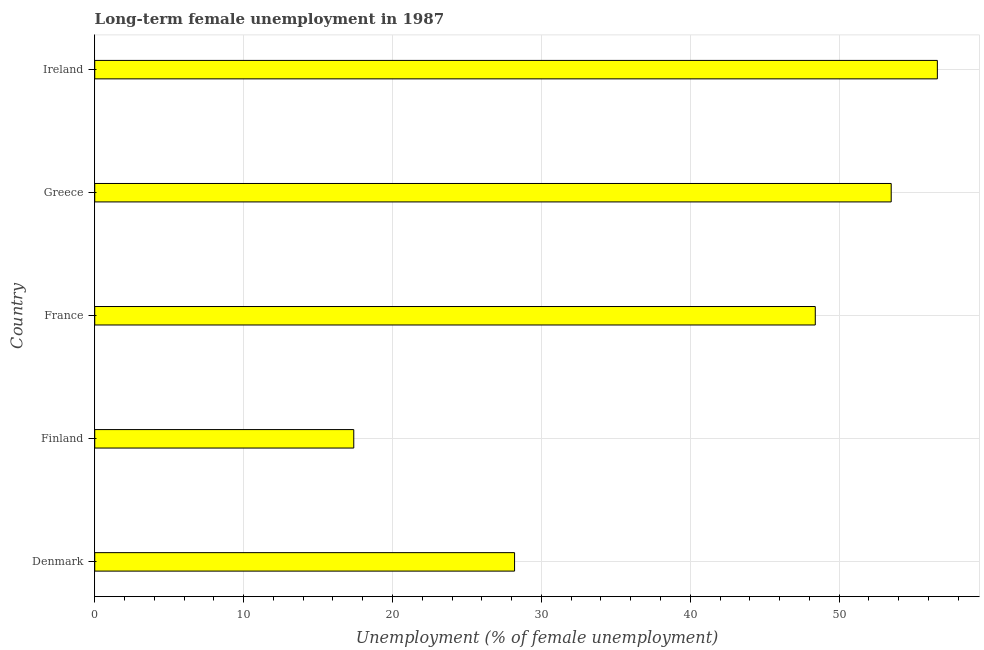What is the title of the graph?
Offer a terse response. Long-term female unemployment in 1987. What is the label or title of the X-axis?
Keep it short and to the point. Unemployment (% of female unemployment). What is the label or title of the Y-axis?
Provide a succinct answer. Country. What is the long-term female unemployment in France?
Offer a terse response. 48.4. Across all countries, what is the maximum long-term female unemployment?
Provide a short and direct response. 56.6. Across all countries, what is the minimum long-term female unemployment?
Offer a very short reply. 17.4. In which country was the long-term female unemployment maximum?
Offer a very short reply. Ireland. What is the sum of the long-term female unemployment?
Your answer should be compact. 204.1. What is the difference between the long-term female unemployment in Greece and Ireland?
Offer a very short reply. -3.1. What is the average long-term female unemployment per country?
Your answer should be compact. 40.82. What is the median long-term female unemployment?
Your answer should be very brief. 48.4. What is the ratio of the long-term female unemployment in Denmark to that in Greece?
Offer a terse response. 0.53. Is the difference between the long-term female unemployment in France and Greece greater than the difference between any two countries?
Keep it short and to the point. No. What is the difference between the highest and the lowest long-term female unemployment?
Make the answer very short. 39.2. Are all the bars in the graph horizontal?
Provide a succinct answer. Yes. How many countries are there in the graph?
Provide a succinct answer. 5. Are the values on the major ticks of X-axis written in scientific E-notation?
Your response must be concise. No. What is the Unemployment (% of female unemployment) of Denmark?
Your answer should be very brief. 28.2. What is the Unemployment (% of female unemployment) of Finland?
Offer a terse response. 17.4. What is the Unemployment (% of female unemployment) of France?
Your response must be concise. 48.4. What is the Unemployment (% of female unemployment) in Greece?
Give a very brief answer. 53.5. What is the Unemployment (% of female unemployment) in Ireland?
Provide a succinct answer. 56.6. What is the difference between the Unemployment (% of female unemployment) in Denmark and France?
Provide a succinct answer. -20.2. What is the difference between the Unemployment (% of female unemployment) in Denmark and Greece?
Your answer should be very brief. -25.3. What is the difference between the Unemployment (% of female unemployment) in Denmark and Ireland?
Your answer should be very brief. -28.4. What is the difference between the Unemployment (% of female unemployment) in Finland and France?
Your response must be concise. -31. What is the difference between the Unemployment (% of female unemployment) in Finland and Greece?
Ensure brevity in your answer.  -36.1. What is the difference between the Unemployment (% of female unemployment) in Finland and Ireland?
Ensure brevity in your answer.  -39.2. What is the difference between the Unemployment (% of female unemployment) in France and Greece?
Ensure brevity in your answer.  -5.1. What is the difference between the Unemployment (% of female unemployment) in France and Ireland?
Make the answer very short. -8.2. What is the difference between the Unemployment (% of female unemployment) in Greece and Ireland?
Provide a succinct answer. -3.1. What is the ratio of the Unemployment (% of female unemployment) in Denmark to that in Finland?
Keep it short and to the point. 1.62. What is the ratio of the Unemployment (% of female unemployment) in Denmark to that in France?
Give a very brief answer. 0.58. What is the ratio of the Unemployment (% of female unemployment) in Denmark to that in Greece?
Provide a succinct answer. 0.53. What is the ratio of the Unemployment (% of female unemployment) in Denmark to that in Ireland?
Offer a very short reply. 0.5. What is the ratio of the Unemployment (% of female unemployment) in Finland to that in France?
Provide a succinct answer. 0.36. What is the ratio of the Unemployment (% of female unemployment) in Finland to that in Greece?
Provide a succinct answer. 0.33. What is the ratio of the Unemployment (% of female unemployment) in Finland to that in Ireland?
Make the answer very short. 0.31. What is the ratio of the Unemployment (% of female unemployment) in France to that in Greece?
Offer a very short reply. 0.91. What is the ratio of the Unemployment (% of female unemployment) in France to that in Ireland?
Offer a very short reply. 0.85. What is the ratio of the Unemployment (% of female unemployment) in Greece to that in Ireland?
Offer a terse response. 0.94. 